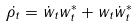Convert formula to latex. <formula><loc_0><loc_0><loc_500><loc_500>\dot { \rho _ { t } } = \dot { w } _ { t } w ^ { * } _ { t } + w _ { t } \dot { w } ^ { * } _ { t }</formula> 